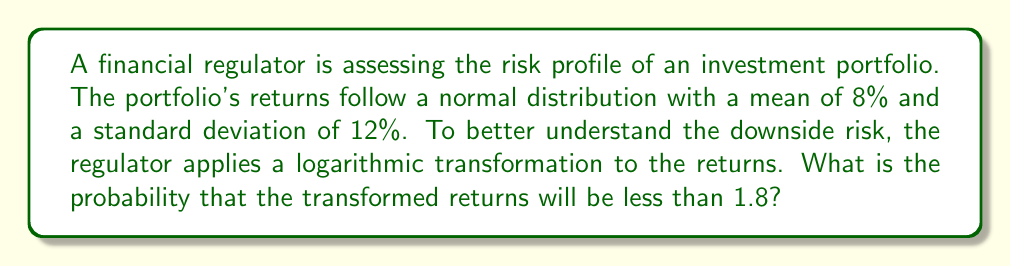Teach me how to tackle this problem. To solve this problem, we'll follow these steps:

1) The original distribution is normal with $\mu = 8\%$ and $\sigma = 12\%$.

2) We apply a logarithmic transformation. If $X$ is the original return, we're interested in $Y = \ln(X)$.

3) For a lognormal distribution, if $X \sim N(\mu, \sigma^2)$, then $Y = \ln(X)$ follows a normal distribution with:

   $\mu_Y = \ln(\frac{\mu^2}{\sqrt{\mu^2 + \sigma^2}})$
   $\sigma_Y^2 = \ln(1 + \frac{\sigma^2}{\mu^2})$

4) Let's calculate these parameters:

   $\mu_Y = \ln(\frac{0.08^2}{\sqrt{0.08^2 + 0.12^2}}) = \ln(0.0064 / 0.1442) = -3.1155$

   $\sigma_Y^2 = \ln(1 + \frac{0.12^2}{0.08^2}) = \ln(3.25) = 1.1787$
   $\sigma_Y = \sqrt{1.1787} = 1.0857$

5) Now we have $Y \sim N(-3.1155, 1.0857^2)$

6) We want to find $P(Y < 1.8)$. We can standardize this:

   $Z = \frac{Y - \mu_Y}{\sigma_Y} = \frac{1.8 - (-3.1155)}{1.0857} = 4.5322$

7) We need to find $P(Z < 4.5322)$. Using a standard normal table or calculator:

   $P(Z < 4.5322) \approx 0.99999$
Answer: 0.99999 